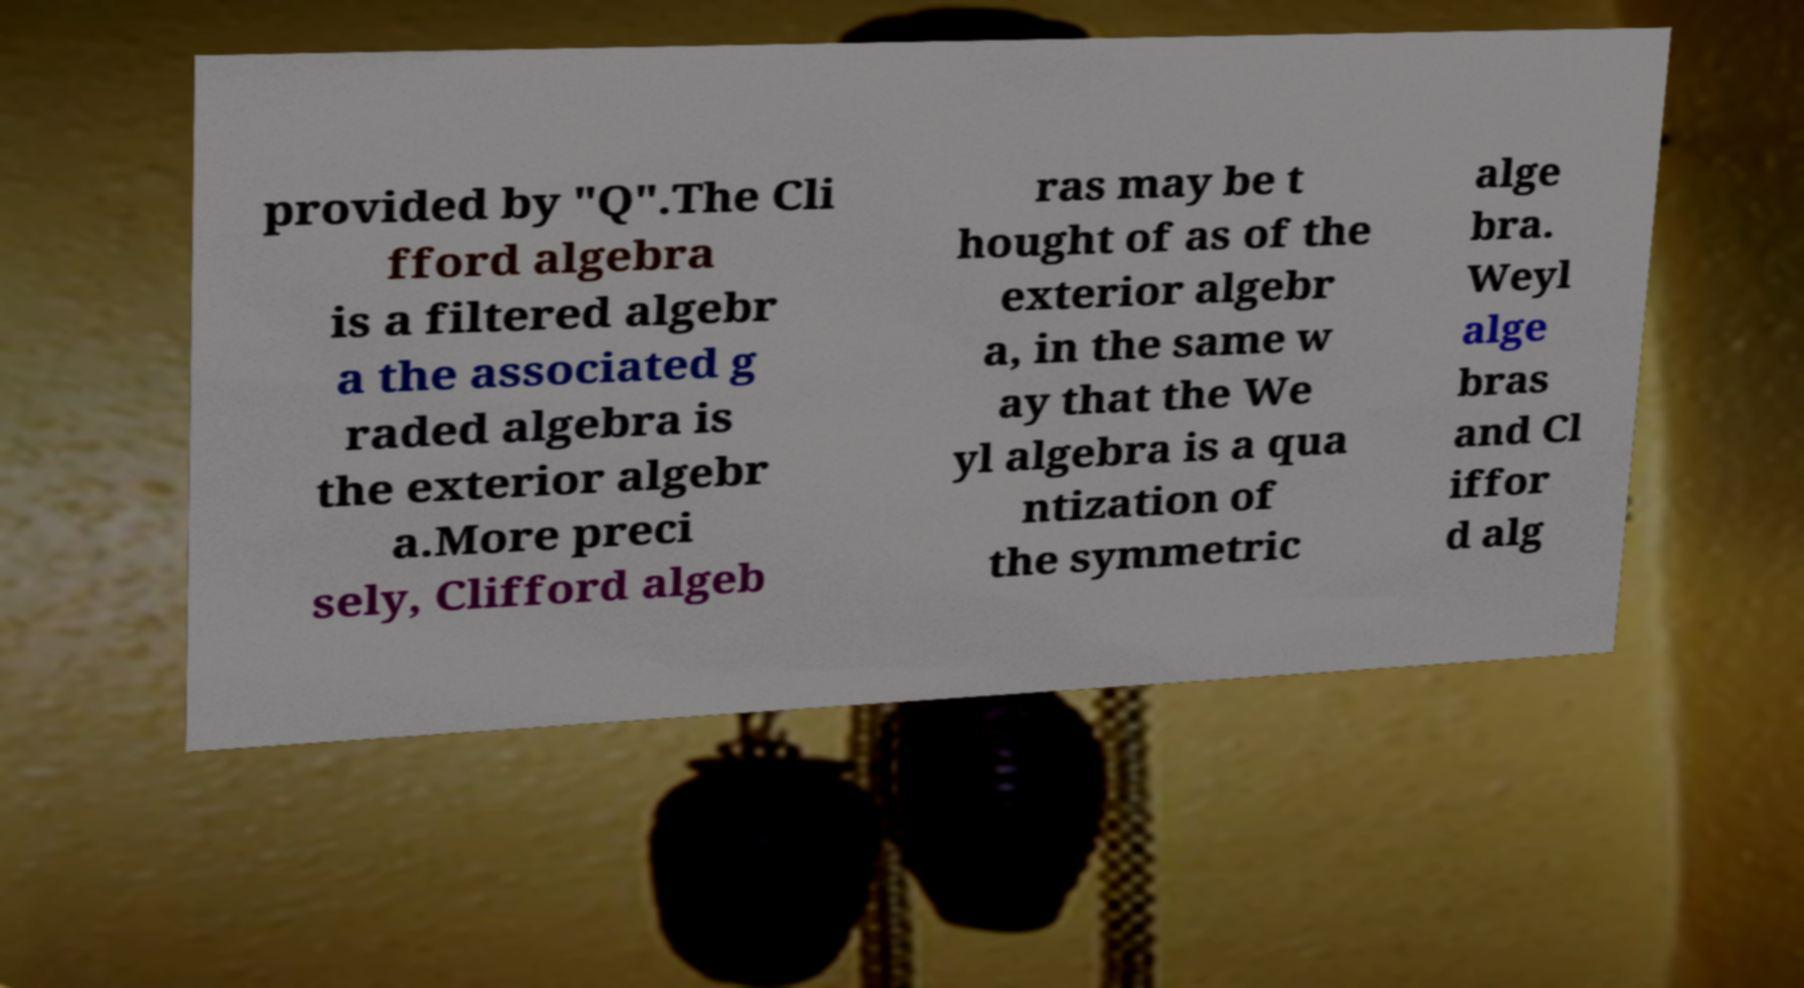Could you assist in decoding the text presented in this image and type it out clearly? provided by "Q".The Cli fford algebra is a filtered algebr a the associated g raded algebra is the exterior algebr a.More preci sely, Clifford algeb ras may be t hought of as of the exterior algebr a, in the same w ay that the We yl algebra is a qua ntization of the symmetric alge bra. Weyl alge bras and Cl iffor d alg 